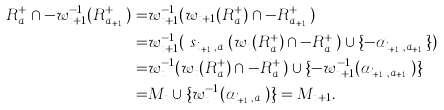Convert formula to latex. <formula><loc_0><loc_0><loc_500><loc_500>R ^ { + } _ { a } \cap - w _ { t + 1 } ^ { - 1 } ( R ^ { + } _ { a _ { t + 1 } } ) = & w ^ { - 1 } _ { t + 1 } ( w _ { t + 1 } ( R ^ { + } _ { a } ) \cap - R ^ { + } _ { a _ { t + 1 } } ) \\ = & w ^ { - 1 } _ { t + 1 } ( \ s _ { i _ { t + 1 } , a _ { t } } ( w _ { t } ( R ^ { + } _ { a } ) \cap - R ^ { + } _ { a _ { t } } ) \cup \{ - \alpha _ { i _ { t + 1 } , a _ { t + 1 } } \} ) \\ = & w ^ { - 1 } _ { t } ( w _ { t } ( R ^ { + } _ { a } ) \cap - R ^ { + } _ { a _ { t } } ) \cup \{ - w ^ { - 1 } _ { t + 1 } ( \alpha _ { i _ { t + 1 } , a _ { t + 1 } } ) \} \\ = & M _ { t } \cup \{ w ^ { - 1 } _ { t } ( \alpha _ { i _ { t + 1 } , a _ { t } } ) \} = M _ { t + 1 } .</formula> 